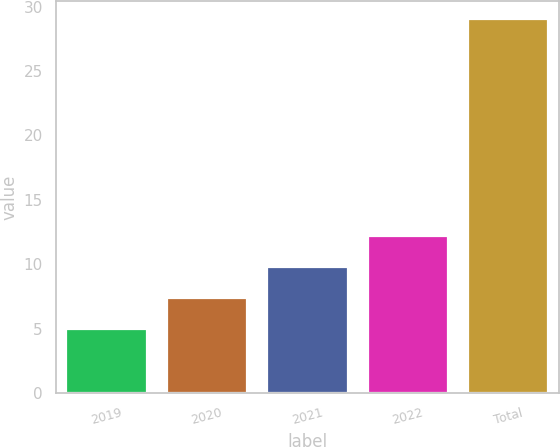Convert chart to OTSL. <chart><loc_0><loc_0><loc_500><loc_500><bar_chart><fcel>2019<fcel>2020<fcel>2021<fcel>2022<fcel>Total<nl><fcel>5<fcel>7.4<fcel>9.8<fcel>12.2<fcel>29<nl></chart> 